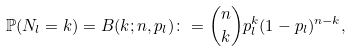Convert formula to latex. <formula><loc_0><loc_0><loc_500><loc_500>\mathbb { P } ( N _ { l } = k ) = B ( k ; n , p _ { l } ) \colon = { n \choose k } p _ { l } ^ { k } ( 1 - p _ { l } ) ^ { n - k } ,</formula> 